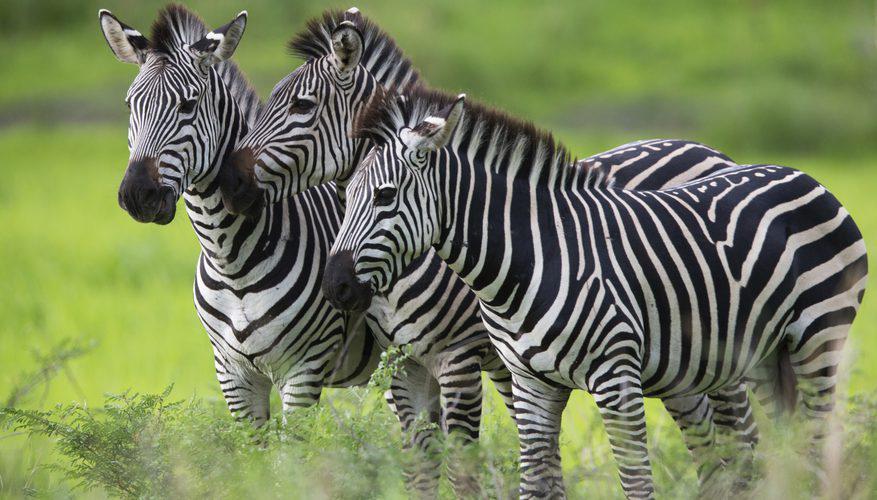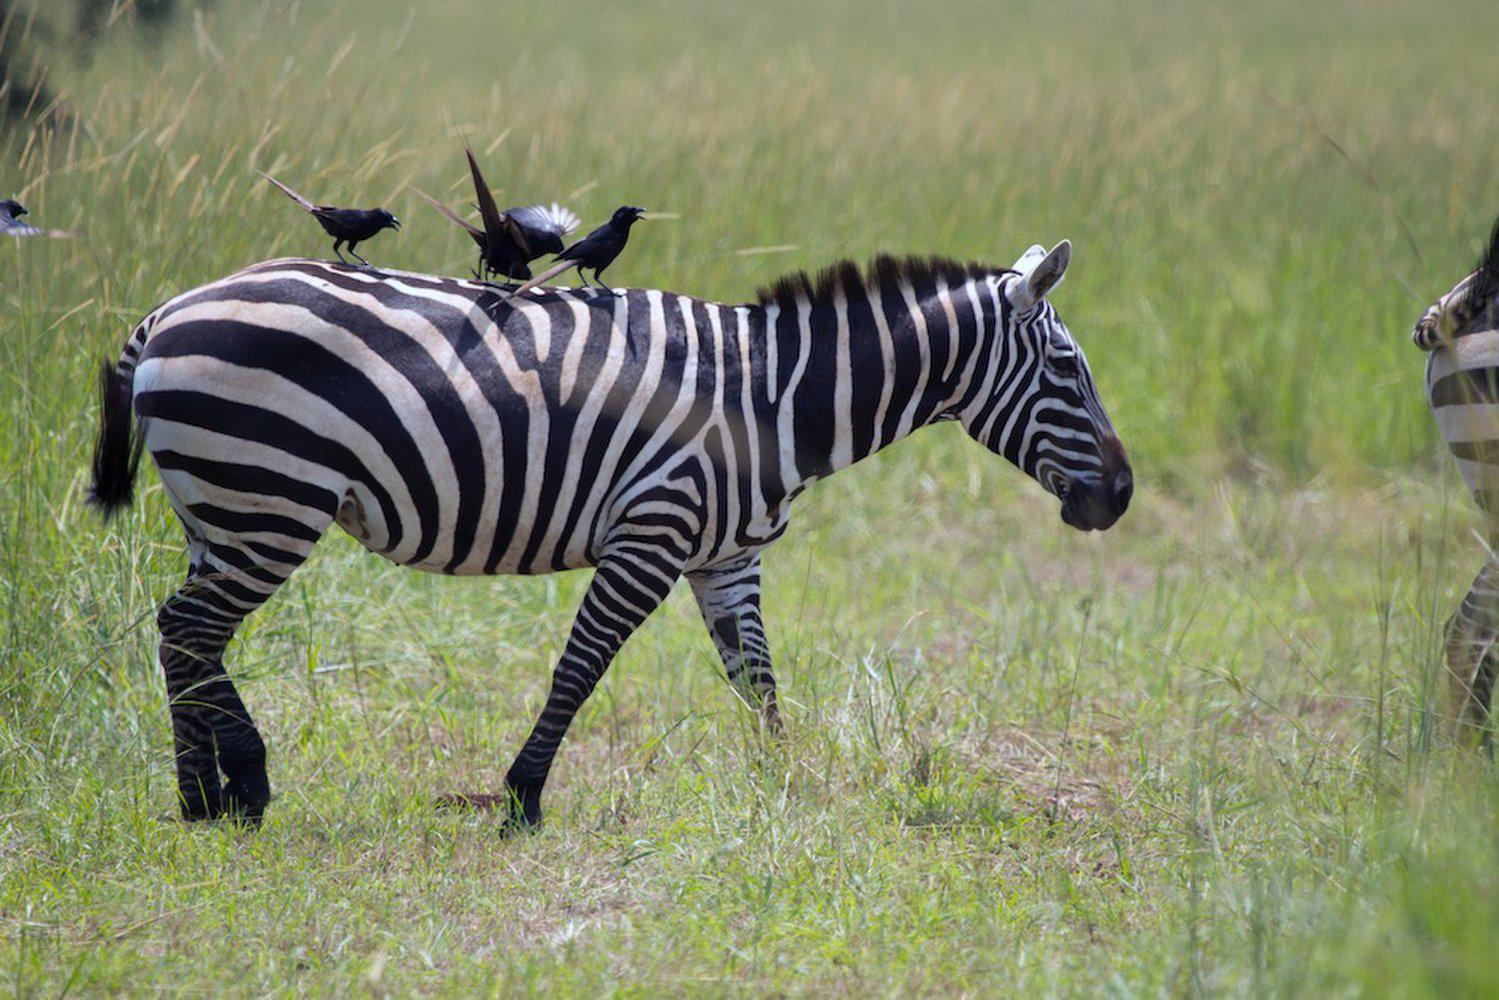The first image is the image on the left, the second image is the image on the right. For the images displayed, is the sentence "Each image contains exactly three zebras, and the zebras in the right and left images face the same direction." factually correct? Answer yes or no. No. The first image is the image on the left, the second image is the image on the right. For the images displayed, is the sentence "There are 6 zebras in total." factually correct? Answer yes or no. No. 